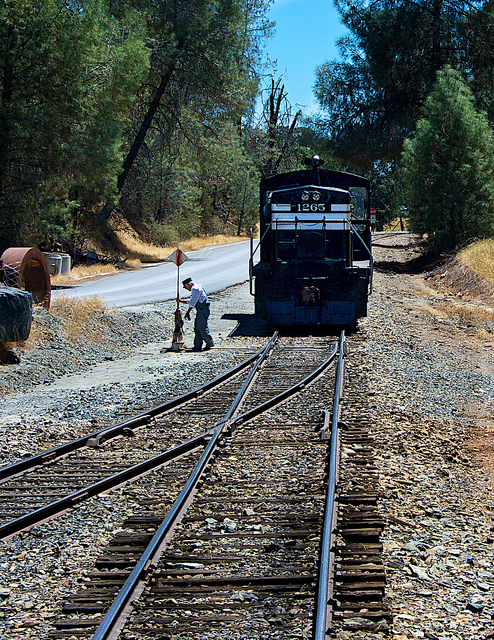What seems to be the focus of the photo? The focus of the photo is the lone individual standing on the railroad tracks in front of the stationary locomotive. The person's activity, whether for maintenance, inspection, or signaling, appears to be the main subject of this image. 